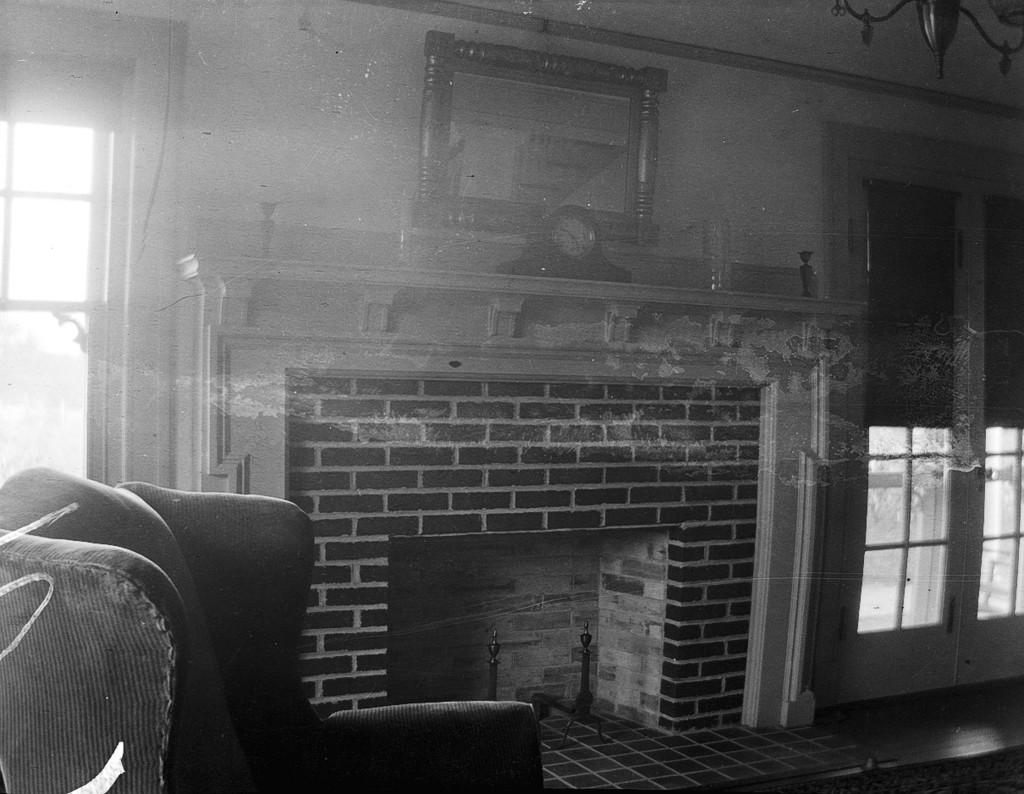What type of space is shown in the image? The image depicts a complete room. What piece of furniture can be seen in the room? There is a couch in the room. Is there any source of natural light in the room? Yes, there is a window in the room. Where is the window located in the room? The window is attached to a wall. What type of soup is being served on the couch in the image? There is no soup present in the image; it only shows a couch and a window. Can you tell me how many lettuce leaves are on the floor in the image? There is no lettuce present in the image; it only shows a couch and a window. 